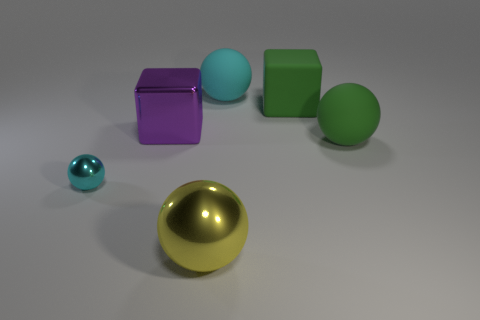Add 3 large yellow matte spheres. How many objects exist? 9 Subtract all blocks. How many objects are left? 4 Add 2 tiny cyan metal spheres. How many tiny cyan metal spheres exist? 3 Subtract 0 cyan cylinders. How many objects are left? 6 Subtract all large green matte spheres. Subtract all small yellow cubes. How many objects are left? 5 Add 4 big cyan rubber spheres. How many big cyan rubber spheres are left? 5 